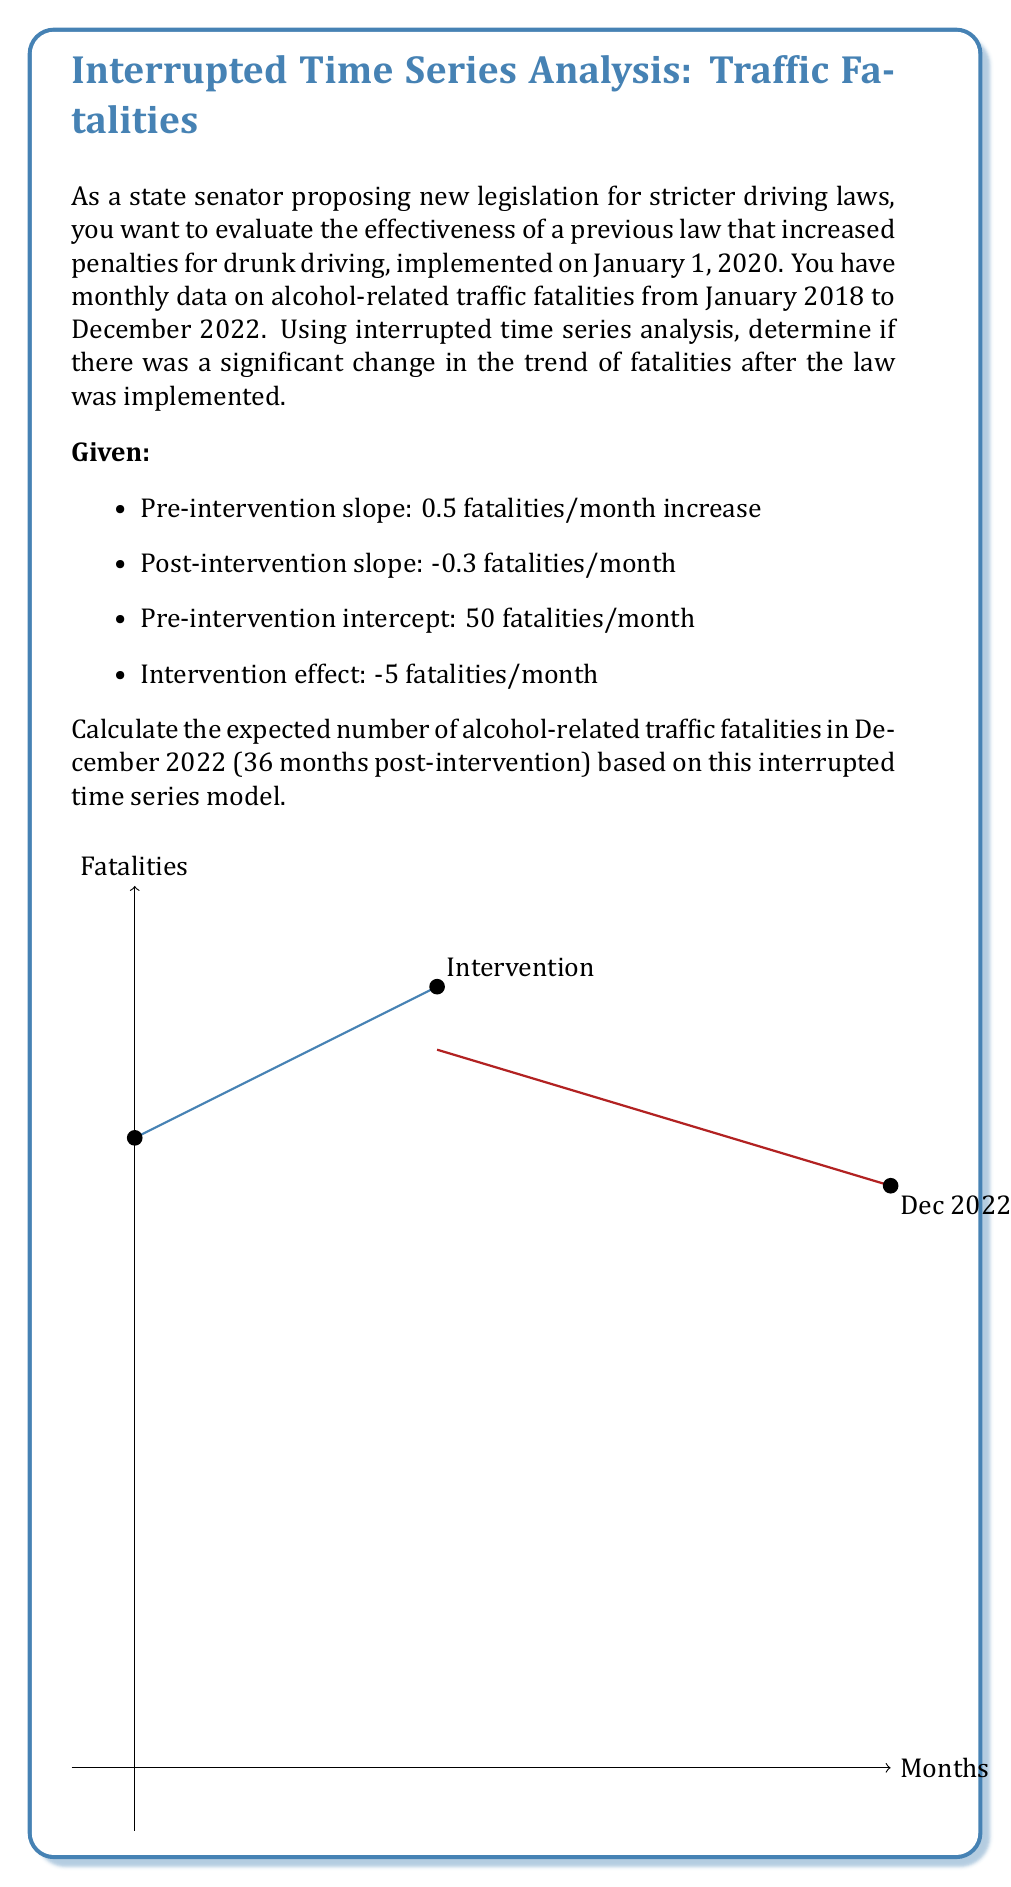Can you solve this math problem? To solve this problem, we'll use the interrupted time series model equation:

$$Y_t = \beta_0 + \beta_1T + \beta_2X_t + \beta_3X_tT + \epsilon_t$$

Where:
- $Y_t$ is the outcome at time $t$
- $T$ is the time since the start of the study
- $X_t$ is a dummy variable (0 pre-intervention, 1 post-intervention)
- $\beta_0$ is the pre-intervention intercept
- $\beta_1$ is the pre-intervention slope
- $\beta_2$ is the level change after intervention
- $\beta_3$ is the slope change after intervention

Step 1: Identify the parameters
- $\beta_0 = 50$ (pre-intervention intercept)
- $\beta_1 = 0.5$ (pre-intervention slope)
- $\beta_2 = -5$ (intervention effect / level change)
- $\beta_3 = -0.3 - 0.5 = -0.8$ (slope change)

Step 2: Determine the values for December 2022
- $T = 60$ (60 months from January 2018 to December 2022)
- $X_t = 1$ (post-intervention)

Step 3: Plug the values into the equation
$$Y_{60} = 50 + 0.5(60) + (-5)(1) + (-0.8)(1)(60)$$

Step 4: Calculate
$$Y_{60} = 50 + 30 - 5 - 48 = 27$$

Therefore, the expected number of alcohol-related traffic fatalities in December 2022 is 27.
Answer: 27 fatalities 